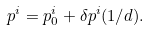Convert formula to latex. <formula><loc_0><loc_0><loc_500><loc_500>p ^ { i } = p _ { 0 } ^ { i } + \delta p ^ { i } ( 1 / d ) .</formula> 